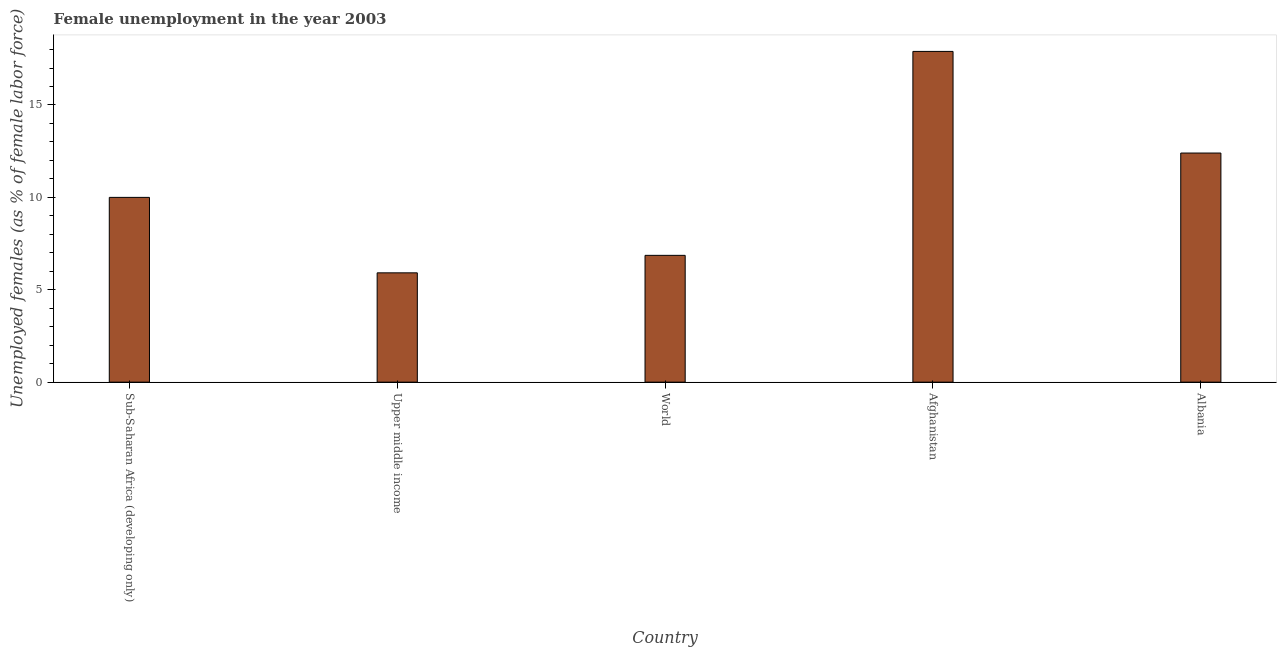Does the graph contain grids?
Give a very brief answer. No. What is the title of the graph?
Provide a succinct answer. Female unemployment in the year 2003. What is the label or title of the Y-axis?
Give a very brief answer. Unemployed females (as % of female labor force). What is the unemployed females population in Albania?
Make the answer very short. 12.4. Across all countries, what is the maximum unemployed females population?
Give a very brief answer. 17.9. Across all countries, what is the minimum unemployed females population?
Provide a short and direct response. 5.92. In which country was the unemployed females population maximum?
Give a very brief answer. Afghanistan. In which country was the unemployed females population minimum?
Your answer should be very brief. Upper middle income. What is the sum of the unemployed females population?
Make the answer very short. 53.08. What is the average unemployed females population per country?
Offer a very short reply. 10.62. What is the median unemployed females population?
Your response must be concise. 10. In how many countries, is the unemployed females population greater than 4 %?
Keep it short and to the point. 5. What is the ratio of the unemployed females population in Upper middle income to that in World?
Offer a very short reply. 0.86. What is the difference between the highest and the second highest unemployed females population?
Your answer should be very brief. 5.5. What is the difference between the highest and the lowest unemployed females population?
Offer a very short reply. 11.98. Are all the bars in the graph horizontal?
Give a very brief answer. No. How many countries are there in the graph?
Offer a very short reply. 5. What is the Unemployed females (as % of female labor force) of Sub-Saharan Africa (developing only)?
Provide a succinct answer. 10. What is the Unemployed females (as % of female labor force) in Upper middle income?
Make the answer very short. 5.92. What is the Unemployed females (as % of female labor force) in World?
Give a very brief answer. 6.86. What is the Unemployed females (as % of female labor force) in Afghanistan?
Your answer should be very brief. 17.9. What is the Unemployed females (as % of female labor force) in Albania?
Provide a short and direct response. 12.4. What is the difference between the Unemployed females (as % of female labor force) in Sub-Saharan Africa (developing only) and Upper middle income?
Ensure brevity in your answer.  4.08. What is the difference between the Unemployed females (as % of female labor force) in Sub-Saharan Africa (developing only) and World?
Your answer should be compact. 3.14. What is the difference between the Unemployed females (as % of female labor force) in Sub-Saharan Africa (developing only) and Afghanistan?
Offer a terse response. -7.9. What is the difference between the Unemployed females (as % of female labor force) in Sub-Saharan Africa (developing only) and Albania?
Give a very brief answer. -2.4. What is the difference between the Unemployed females (as % of female labor force) in Upper middle income and World?
Provide a short and direct response. -0.95. What is the difference between the Unemployed females (as % of female labor force) in Upper middle income and Afghanistan?
Your answer should be compact. -11.98. What is the difference between the Unemployed females (as % of female labor force) in Upper middle income and Albania?
Provide a succinct answer. -6.48. What is the difference between the Unemployed females (as % of female labor force) in World and Afghanistan?
Keep it short and to the point. -11.04. What is the difference between the Unemployed females (as % of female labor force) in World and Albania?
Ensure brevity in your answer.  -5.54. What is the ratio of the Unemployed females (as % of female labor force) in Sub-Saharan Africa (developing only) to that in Upper middle income?
Offer a very short reply. 1.69. What is the ratio of the Unemployed females (as % of female labor force) in Sub-Saharan Africa (developing only) to that in World?
Your response must be concise. 1.46. What is the ratio of the Unemployed females (as % of female labor force) in Sub-Saharan Africa (developing only) to that in Afghanistan?
Your answer should be very brief. 0.56. What is the ratio of the Unemployed females (as % of female labor force) in Sub-Saharan Africa (developing only) to that in Albania?
Your answer should be very brief. 0.81. What is the ratio of the Unemployed females (as % of female labor force) in Upper middle income to that in World?
Offer a terse response. 0.86. What is the ratio of the Unemployed females (as % of female labor force) in Upper middle income to that in Afghanistan?
Your answer should be very brief. 0.33. What is the ratio of the Unemployed females (as % of female labor force) in Upper middle income to that in Albania?
Your answer should be very brief. 0.48. What is the ratio of the Unemployed females (as % of female labor force) in World to that in Afghanistan?
Provide a succinct answer. 0.38. What is the ratio of the Unemployed females (as % of female labor force) in World to that in Albania?
Your answer should be very brief. 0.55. What is the ratio of the Unemployed females (as % of female labor force) in Afghanistan to that in Albania?
Offer a very short reply. 1.44. 